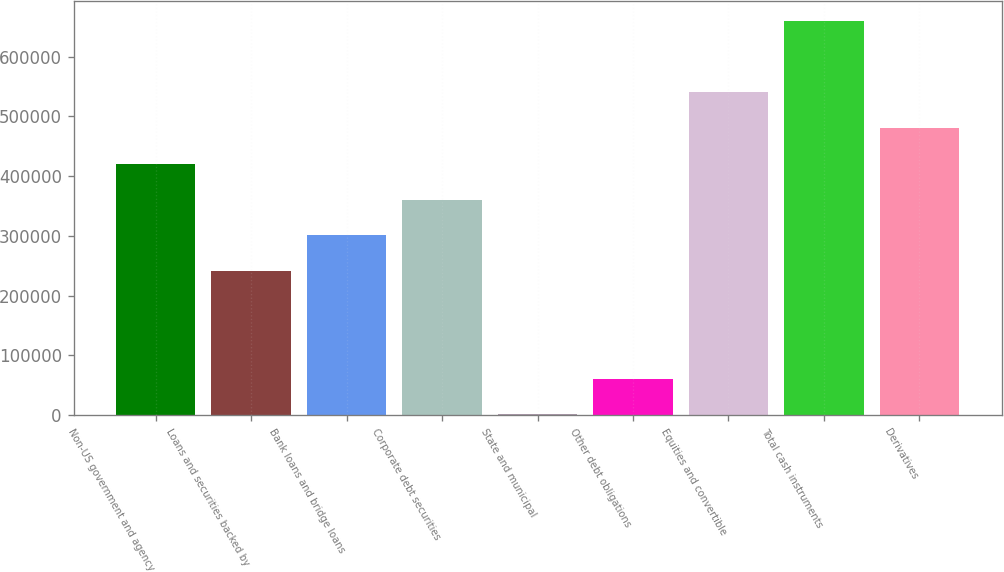<chart> <loc_0><loc_0><loc_500><loc_500><bar_chart><fcel>Non-US government and agency<fcel>Loans and securities backed by<fcel>Bank loans and bridge loans<fcel>Corporate debt securities<fcel>State and municipal<fcel>Other debt obligations<fcel>Equities and convertible<fcel>Total cash instruments<fcel>Derivatives<nl><fcel>420564<fcel>240955<fcel>300824<fcel>360694<fcel>1476<fcel>61345.7<fcel>540303<fcel>660043<fcel>480434<nl></chart> 